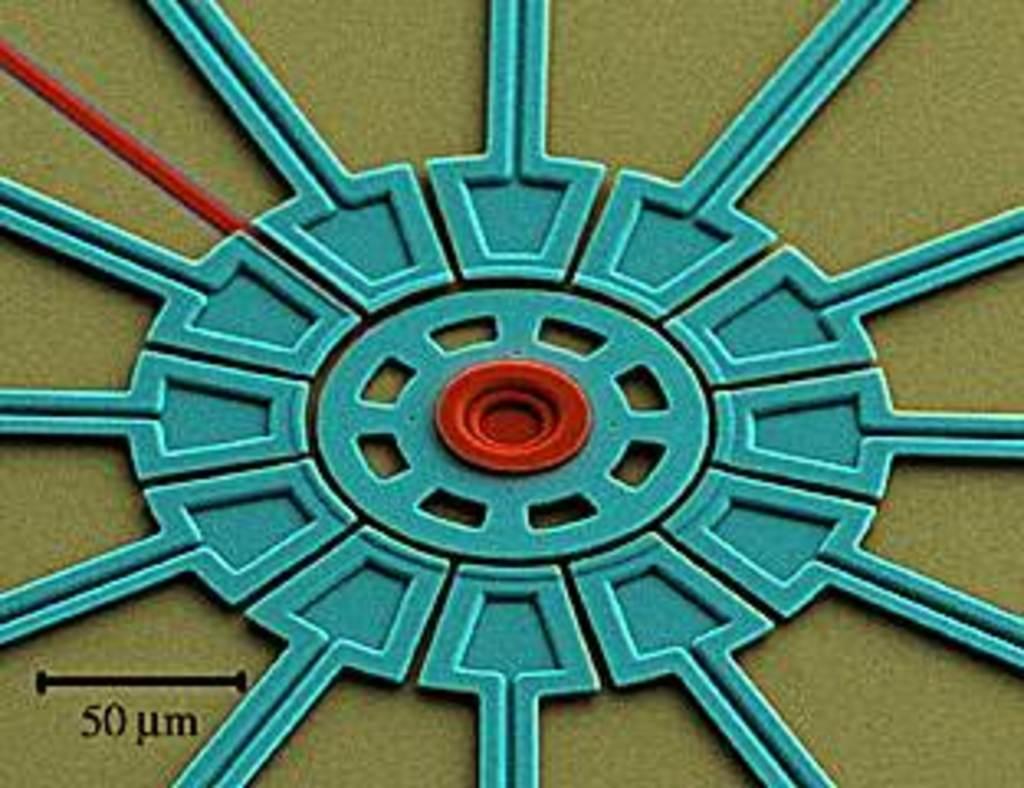Can you describe this image briefly? In this image we can see an animated picture. On the bottom of the image we can see some text and numbers. 